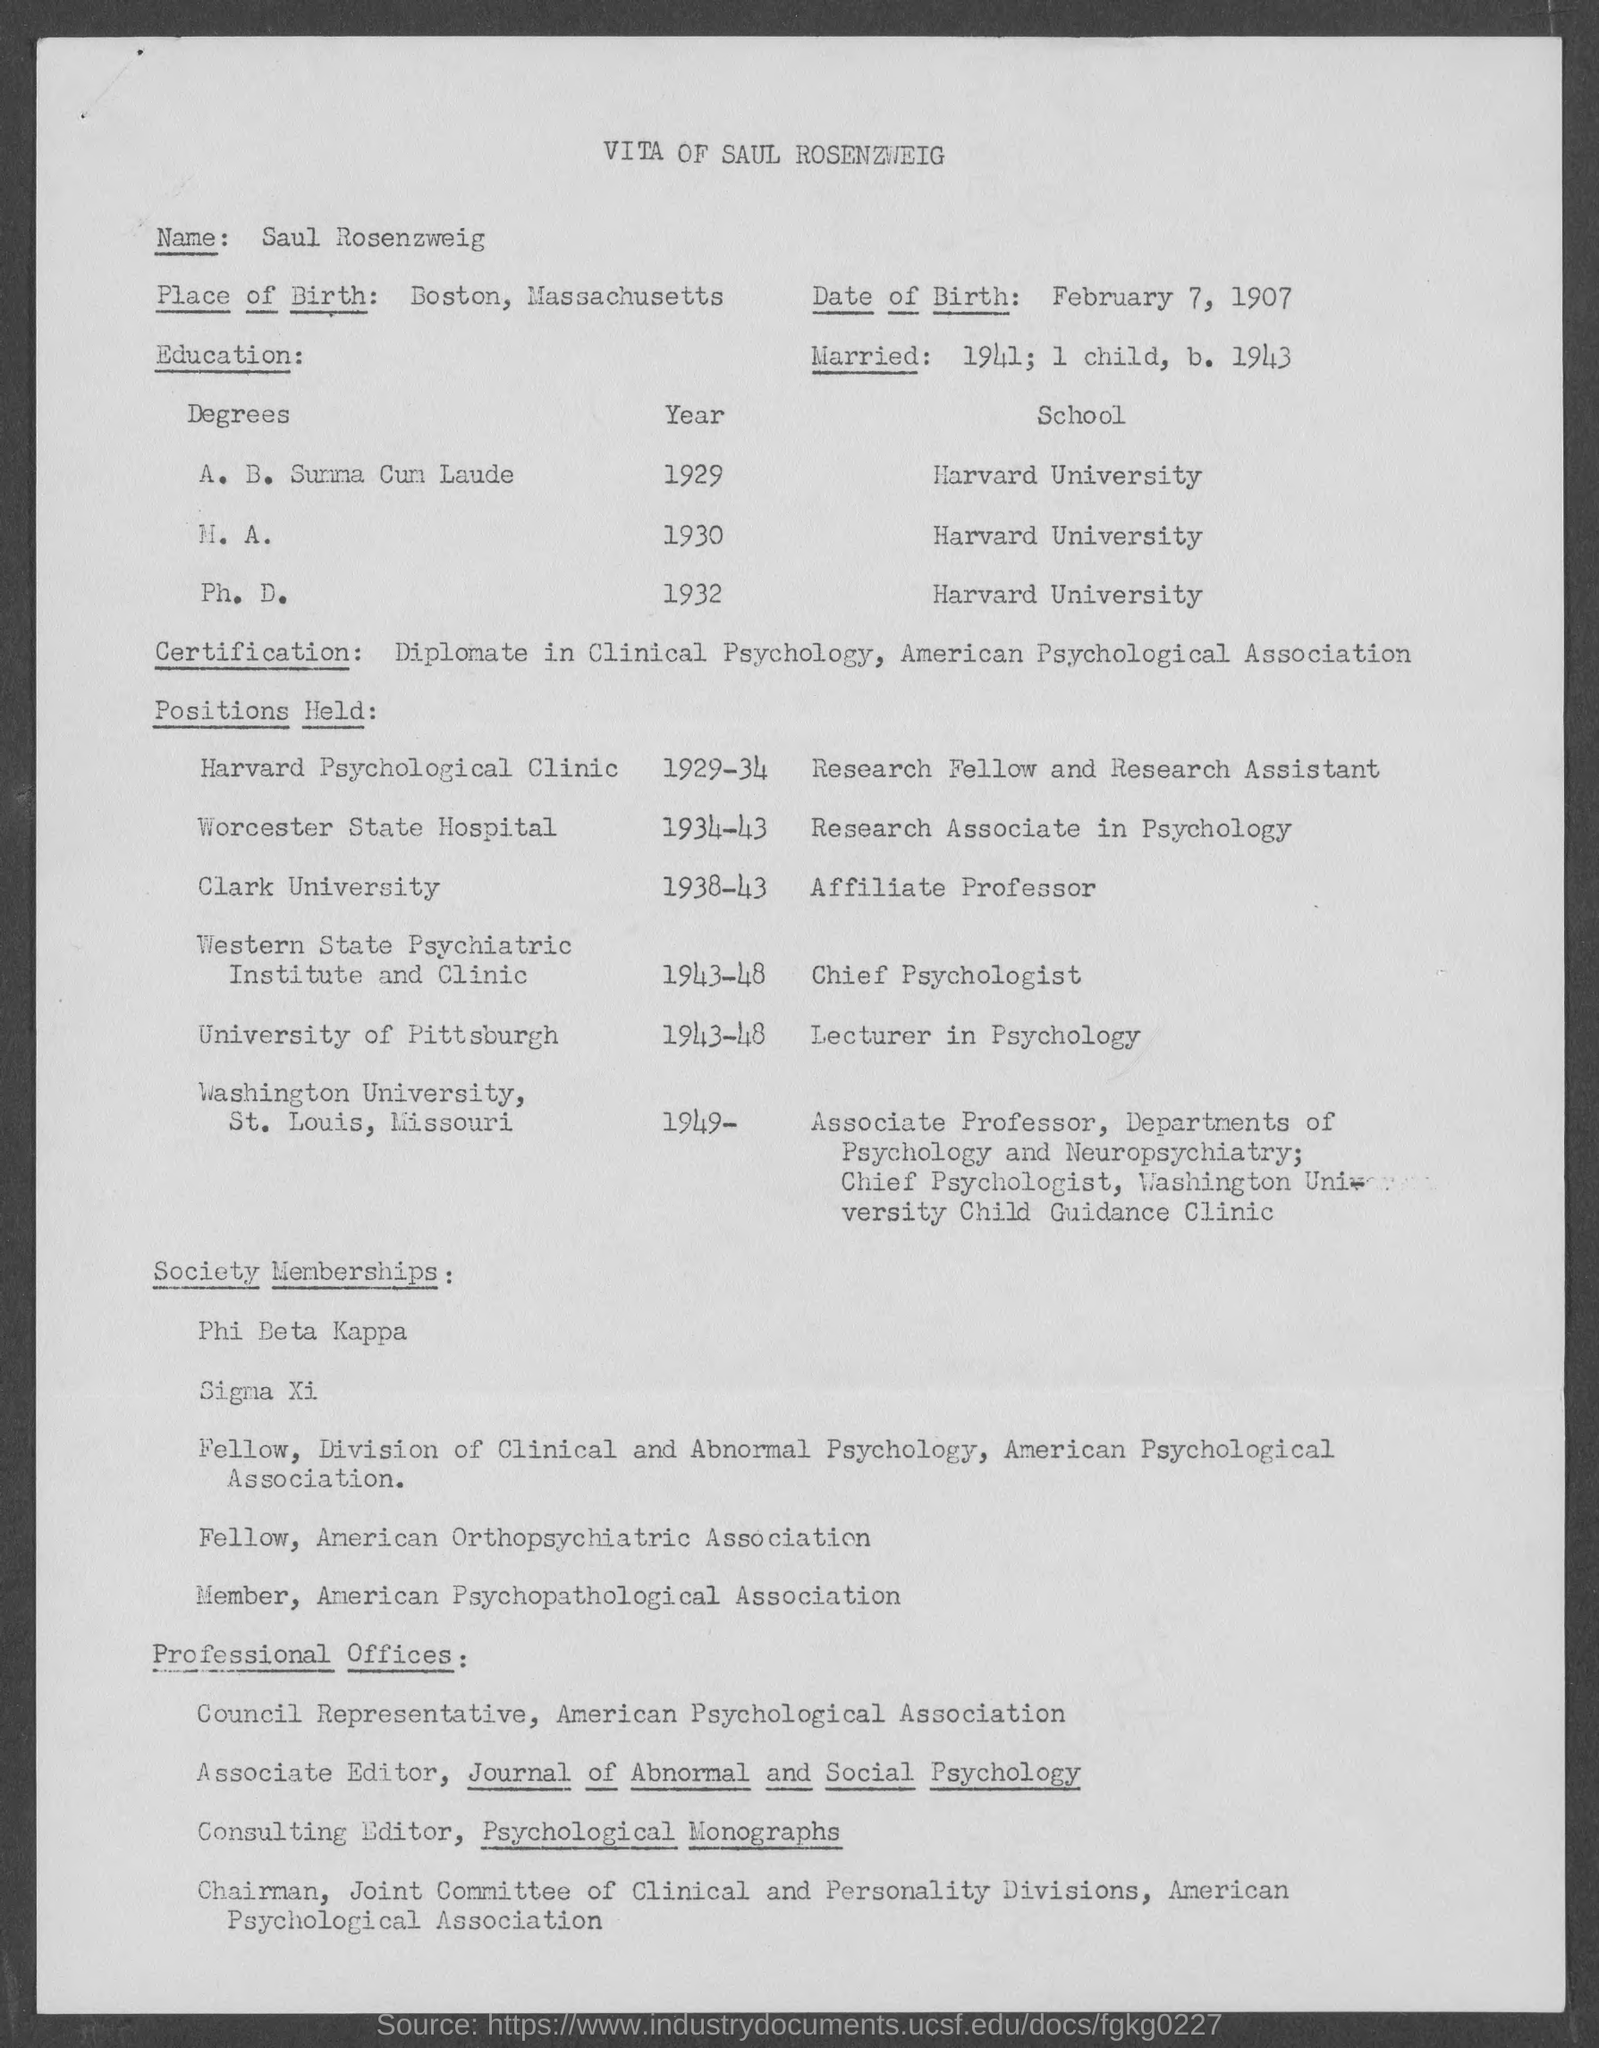Whose profile mentioned in the document?
Provide a short and direct response. Saul Rosenzweig. What is the Date Of  Birth?
Provide a succinct answer. February 7, 1907. Where is the Place Of Birth?
Offer a very short reply. Boston, Massachusetts. On which year he had married?
Ensure brevity in your answer.  1941. Which University he had Ph. D. completed?
Make the answer very short. Harvard University. 